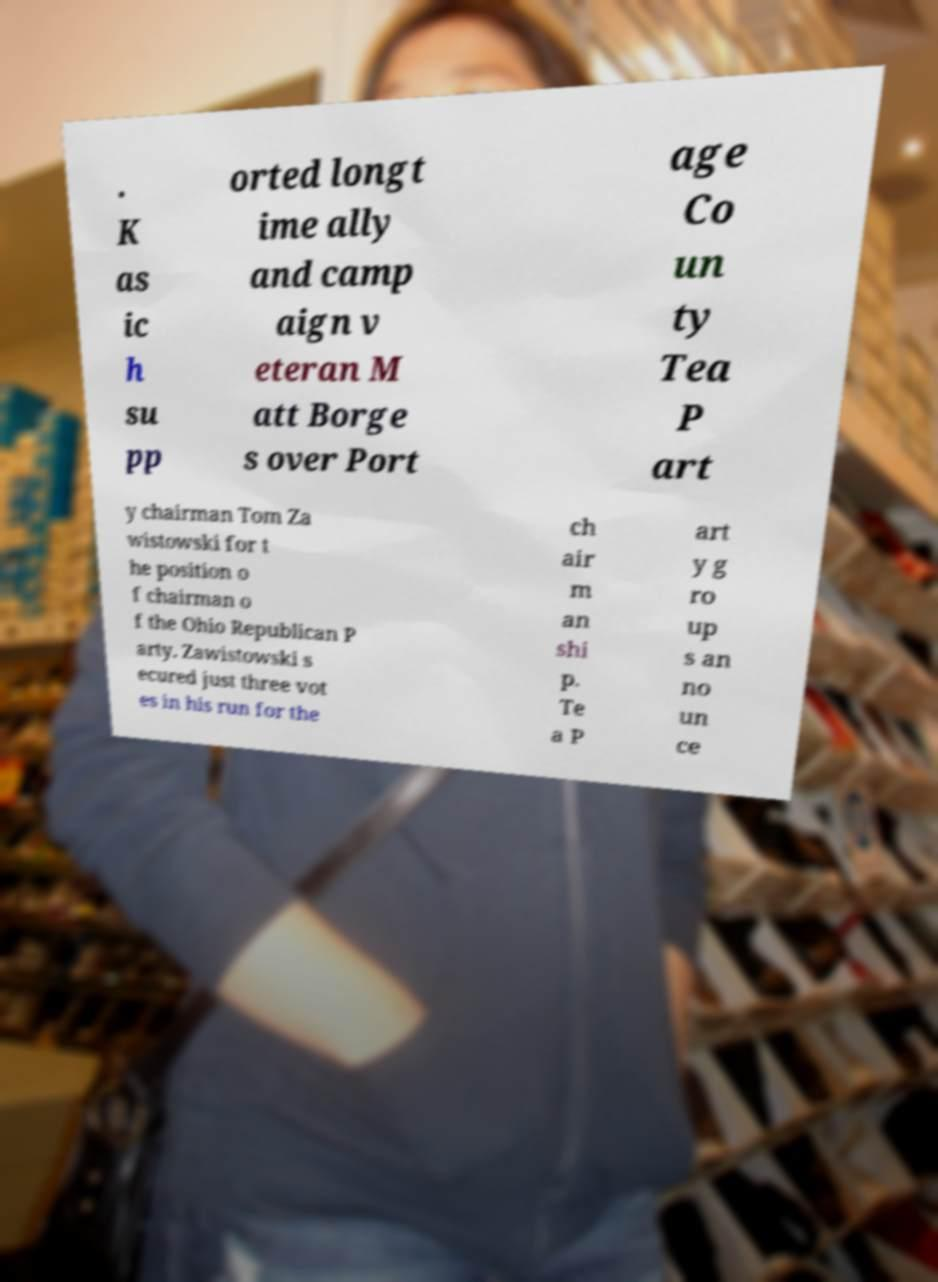Please read and relay the text visible in this image. What does it say? . K as ic h su pp orted longt ime ally and camp aign v eteran M att Borge s over Port age Co un ty Tea P art y chairman Tom Za wistowski for t he position o f chairman o f the Ohio Republican P arty. Zawistowski s ecured just three vot es in his run for the ch air m an shi p. Te a P art y g ro up s an no un ce 